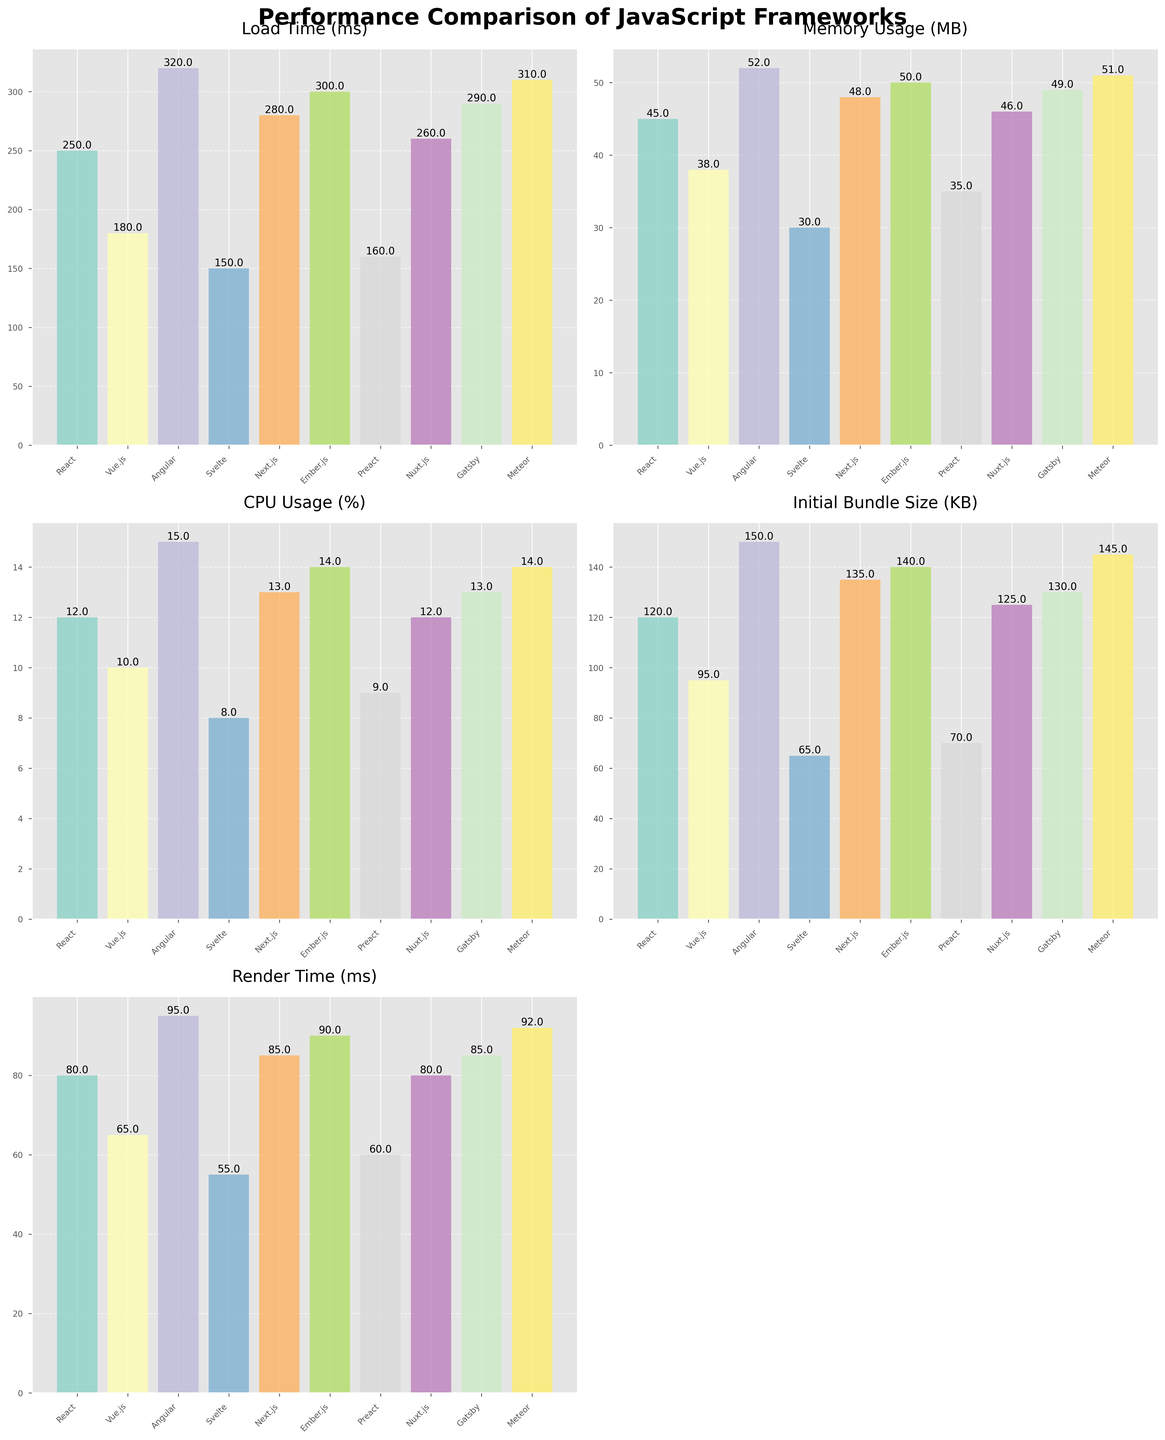What's the title of the figure? The title is located at the top center of the figure in bold font.
Answer: Performance Comparison of JavaScript Frameworks How many subplots are present in the figure? By looking at the grid layout, there are 5 subplots (3 rows with 2 columns with one subplot removed)
Answer: 5 Which JavaScript framework has the lowest memory usage? Look at the 'Memory Usage (MB)' subplot and identify the shortest bar.
Answer: Svelte What is the difference in Render Time (ms) between React and Vue.js? In the 'Render Time (ms)' subplot, React has 80 ms and Vue.js has 65 ms. The difference is 80 - 65.
Answer: 15 ms Which framework has the highest Initial Bundle Size? Refer to the 'Initial Bundle Size (KB)' subplot and identify the tallest bar.
Answer: Angular What is the average CPU Usage (%) across all frameworks? Sum up the CPU usage percentages for all frameworks: (12+10+15+8+13+14+9+12+13+14) and divide by 10.
Answer: 12% Is there any framework that has both Load Time under 200 ms and Memory Usage under 40 MB? Look at the 'Load Time (ms)' subplot to identify frameworks under 200 ms, then check if those frameworks also have Memory Usage under 40 MB in the 'Memory Usage (MB)' subplot.
Answer: Vue.js, Svelte, Preact Which framework has the closest render time to 90 ms? Look at the 'Render Time (ms)' subplot and identify the bar closest to 90 ms.
Answer: Ember.js Between Angular and Svelte, which has better performance in terms of Load Time (ms)? Compare the heights of Angular and Svelte bars in the 'Load Time (ms)' subplot.
Answer: Svelte What is the total Load Time (ms) for all frameworks combined? Add the Load Times for all frameworks: (250 + 180 + 320 + 150 + 280 + 300 + 160 + 260 + 290 + 310).
Answer: 2500 ms 